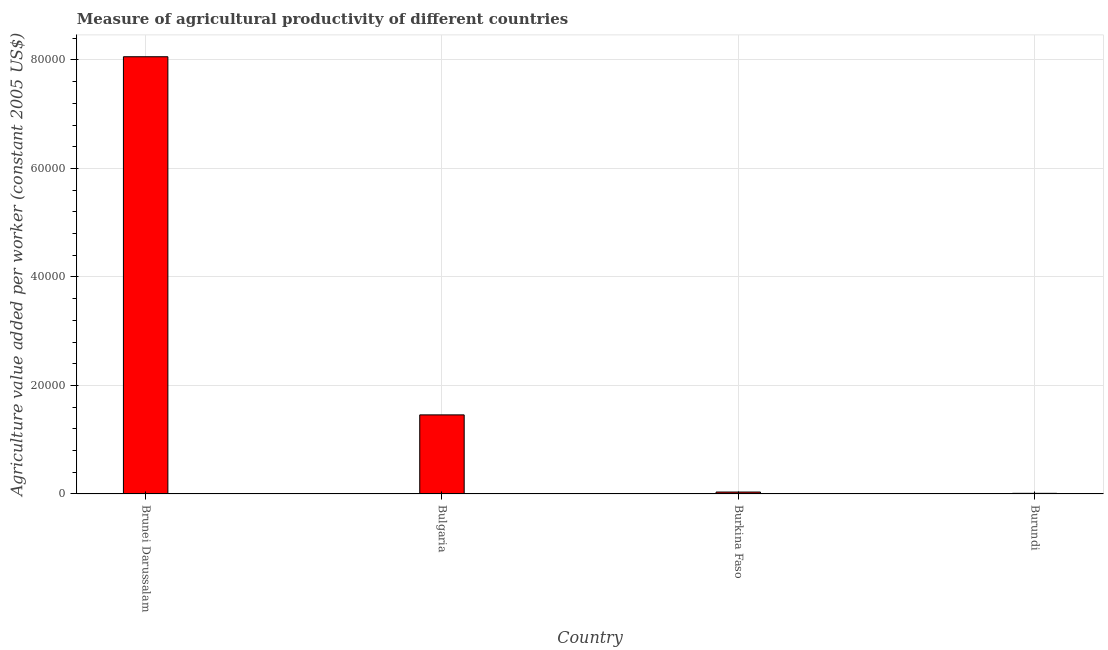Does the graph contain grids?
Give a very brief answer. Yes. What is the title of the graph?
Give a very brief answer. Measure of agricultural productivity of different countries. What is the label or title of the X-axis?
Provide a short and direct response. Country. What is the label or title of the Y-axis?
Your answer should be very brief. Agriculture value added per worker (constant 2005 US$). What is the agriculture value added per worker in Burundi?
Keep it short and to the point. 117.91. Across all countries, what is the maximum agriculture value added per worker?
Your answer should be very brief. 8.06e+04. Across all countries, what is the minimum agriculture value added per worker?
Give a very brief answer. 117.91. In which country was the agriculture value added per worker maximum?
Make the answer very short. Brunei Darussalam. In which country was the agriculture value added per worker minimum?
Keep it short and to the point. Burundi. What is the sum of the agriculture value added per worker?
Your answer should be very brief. 9.56e+04. What is the difference between the agriculture value added per worker in Bulgaria and Burundi?
Your answer should be very brief. 1.45e+04. What is the average agriculture value added per worker per country?
Give a very brief answer. 2.39e+04. What is the median agriculture value added per worker?
Your answer should be very brief. 7466.5. In how many countries, is the agriculture value added per worker greater than 24000 US$?
Provide a succinct answer. 1. What is the ratio of the agriculture value added per worker in Bulgaria to that in Burundi?
Keep it short and to the point. 123.63. Is the agriculture value added per worker in Bulgaria less than that in Burundi?
Keep it short and to the point. No. What is the difference between the highest and the second highest agriculture value added per worker?
Ensure brevity in your answer.  6.60e+04. Is the sum of the agriculture value added per worker in Brunei Darussalam and Bulgaria greater than the maximum agriculture value added per worker across all countries?
Offer a terse response. Yes. What is the difference between the highest and the lowest agriculture value added per worker?
Your response must be concise. 8.05e+04. What is the difference between two consecutive major ticks on the Y-axis?
Your answer should be very brief. 2.00e+04. What is the Agriculture value added per worker (constant 2005 US$) of Brunei Darussalam?
Provide a short and direct response. 8.06e+04. What is the Agriculture value added per worker (constant 2005 US$) of Bulgaria?
Provide a short and direct response. 1.46e+04. What is the Agriculture value added per worker (constant 2005 US$) in Burkina Faso?
Your answer should be very brief. 355.16. What is the Agriculture value added per worker (constant 2005 US$) of Burundi?
Provide a short and direct response. 117.91. What is the difference between the Agriculture value added per worker (constant 2005 US$) in Brunei Darussalam and Bulgaria?
Your response must be concise. 6.60e+04. What is the difference between the Agriculture value added per worker (constant 2005 US$) in Brunei Darussalam and Burkina Faso?
Offer a very short reply. 8.02e+04. What is the difference between the Agriculture value added per worker (constant 2005 US$) in Brunei Darussalam and Burundi?
Your answer should be very brief. 8.05e+04. What is the difference between the Agriculture value added per worker (constant 2005 US$) in Bulgaria and Burkina Faso?
Your response must be concise. 1.42e+04. What is the difference between the Agriculture value added per worker (constant 2005 US$) in Bulgaria and Burundi?
Provide a succinct answer. 1.45e+04. What is the difference between the Agriculture value added per worker (constant 2005 US$) in Burkina Faso and Burundi?
Provide a succinct answer. 237.25. What is the ratio of the Agriculture value added per worker (constant 2005 US$) in Brunei Darussalam to that in Bulgaria?
Keep it short and to the point. 5.53. What is the ratio of the Agriculture value added per worker (constant 2005 US$) in Brunei Darussalam to that in Burkina Faso?
Offer a very short reply. 226.93. What is the ratio of the Agriculture value added per worker (constant 2005 US$) in Brunei Darussalam to that in Burundi?
Offer a very short reply. 683.54. What is the ratio of the Agriculture value added per worker (constant 2005 US$) in Bulgaria to that in Burkina Faso?
Make the answer very short. 41.05. What is the ratio of the Agriculture value added per worker (constant 2005 US$) in Bulgaria to that in Burundi?
Offer a very short reply. 123.63. What is the ratio of the Agriculture value added per worker (constant 2005 US$) in Burkina Faso to that in Burundi?
Give a very brief answer. 3.01. 